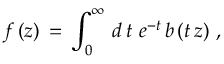<formula> <loc_0><loc_0><loc_500><loc_500>f \, ( z ) \, = \, \int _ { 0 } ^ { \infty } \, d \, t \ e ^ { - t } \, b \, ( t \, z ) \, ,</formula> 